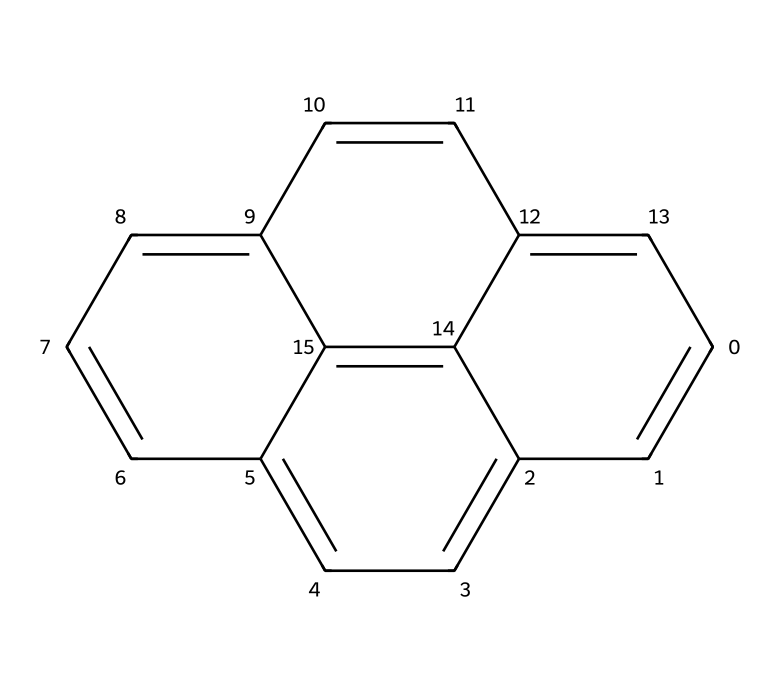What is the molecular formula of pyrene? To determine the molecular formula of pyrene from its SMILES representation, we analyze the structure. Each carbon (c) in the SMILES represents one carbon atom, and from the structure, we count a total of 16 carbon atoms. Since it is a hydrocarbon, we can deduce the number of hydrogen atoms by following the general formula for hydrocarbons, CnH(2n+2), but since pyrene is polycyclic and has some hydrogen atoms replaced due to the fused rings, it actually has 10 hydrogen atoms. Thus, its molecular formula is C16H10.
Answer: C16H10 How many rings does pyrene have? By examining the structured representation from the SMILES, we can identify the rings formed by the connections between carbon atoms. Pyrene consists of four fused aromatic rings, as seen in its structure. Therefore, the number of rings in pyrene is 4.
Answer: 4 What type of hydrocarbon is pyrene classified as? Pyrene is classified as a polycyclic aromatic hydrocarbon (PAH) due to its multiple aromatic rings within its structure, which indicates it is a hydrocarbon featuring fused cyclic arrangements of carbon atoms.
Answer: polycyclic aromatic hydrocarbon Does pyrene contain any heteroatoms? The SMILES representation only shows carbon (c), which indicates that pyrene is composed entirely of carbon and hydrogen atoms. There are no heteroatoms present (such as nitrogen, oxygen, or sulfur) in the structure of pyrene.
Answer: No What is the degree of unsaturation in pyrene? To determine the degree of unsaturation, we can use the formula (1 + 2C - H)/2, where C is the number of carbon atoms and H is the number of hydrogen atoms. Here, C = 16 and H = 10, substituting these values gives (1 + 2(16) - 10)/2 = 11. The degree of unsaturation indicates that pyrene contains 11 pi bonds or rings, correlating with the structure having multiple rings.
Answer: 11 How does pyrene's structure influence its solubility properties? Pyrene's structure, consisting of four fused aromatic rings, makes it non-polar in nature. Non-polar compounds generally have low solubility in water but may be soluble in organic solvents. The lack of polar functional groups in pyrene contributes to its hydrophobic characteristics.
Answer: Non-polar 